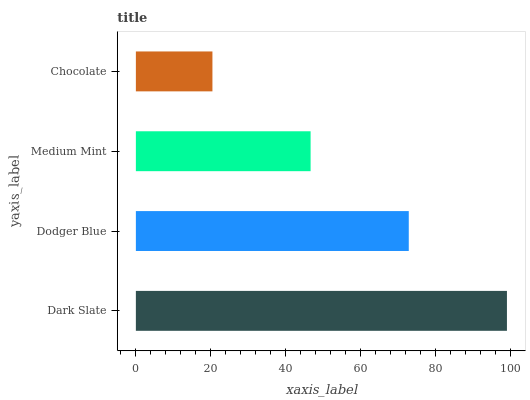Is Chocolate the minimum?
Answer yes or no. Yes. Is Dark Slate the maximum?
Answer yes or no. Yes. Is Dodger Blue the minimum?
Answer yes or no. No. Is Dodger Blue the maximum?
Answer yes or no. No. Is Dark Slate greater than Dodger Blue?
Answer yes or no. Yes. Is Dodger Blue less than Dark Slate?
Answer yes or no. Yes. Is Dodger Blue greater than Dark Slate?
Answer yes or no. No. Is Dark Slate less than Dodger Blue?
Answer yes or no. No. Is Dodger Blue the high median?
Answer yes or no. Yes. Is Medium Mint the low median?
Answer yes or no. Yes. Is Medium Mint the high median?
Answer yes or no. No. Is Dark Slate the low median?
Answer yes or no. No. 